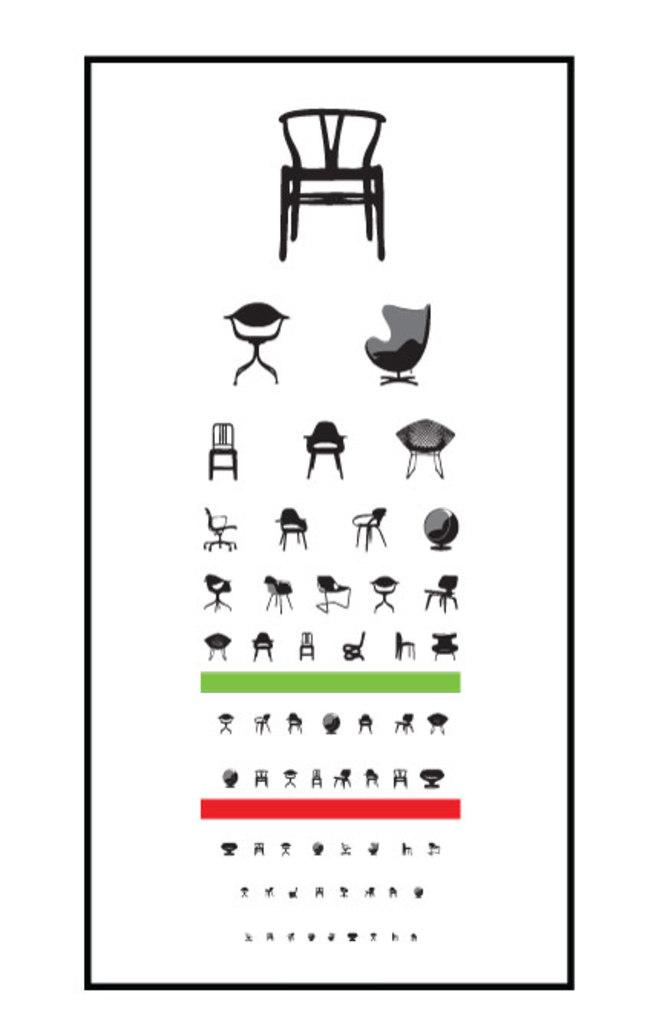What is the main subject of the poster in the image? The main subject of the poster in the image is chairs. Are there any specific colors used in the poster? Yes, there are red and green color lines at the bottom of the poster. What is the background color of the poster? The background of the poster is white. Can you tell me how many dogs are depicted on the poster? There are no dogs depicted on the poster; it features images of chairs. What type of lizards can be seen interacting with the chairs on the poster? There are no lizards present on the poster; it only features images of chairs and color lines. 